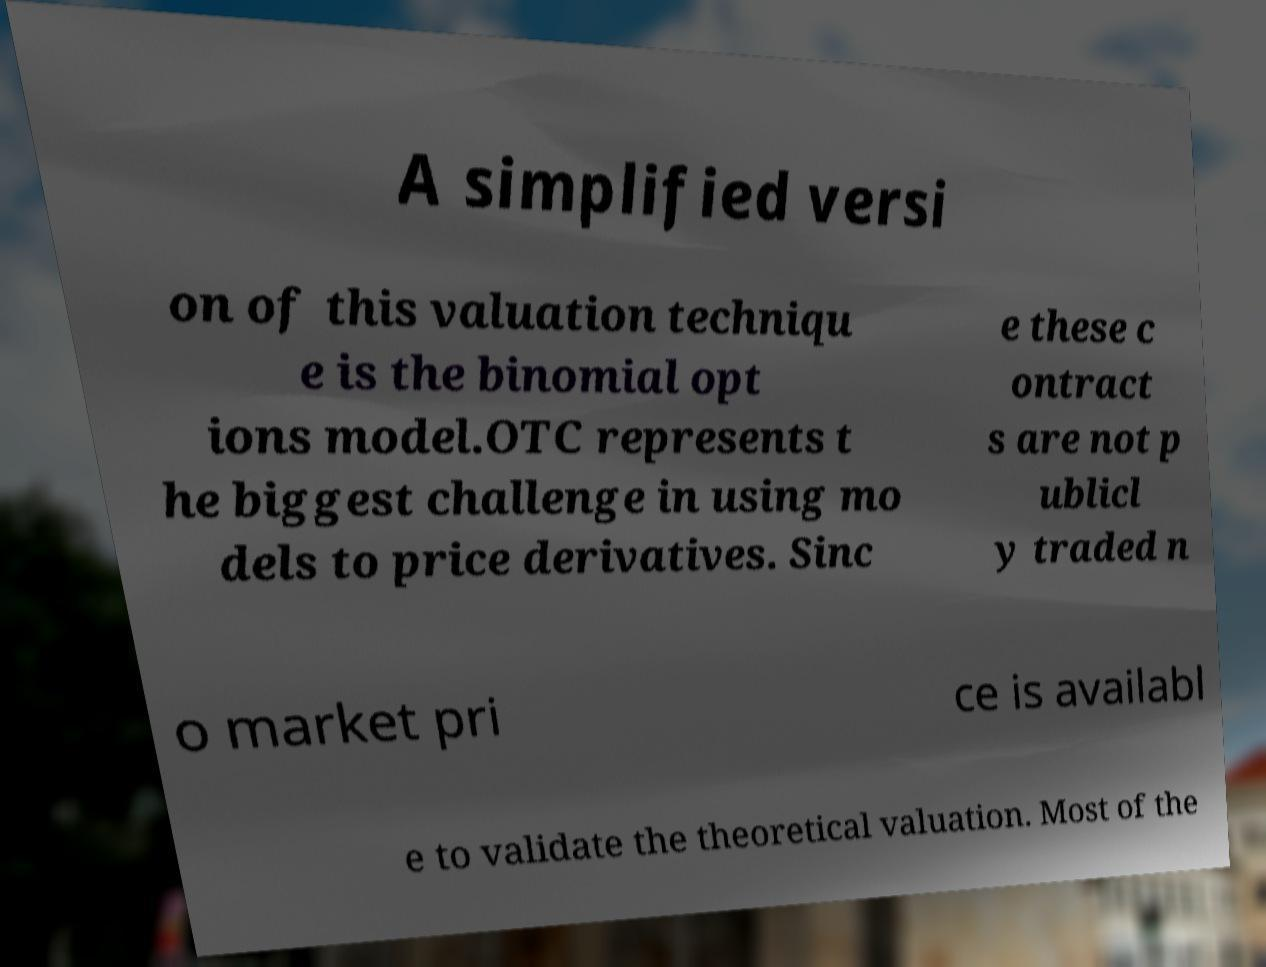Can you accurately transcribe the text from the provided image for me? A simplified versi on of this valuation techniqu e is the binomial opt ions model.OTC represents t he biggest challenge in using mo dels to price derivatives. Sinc e these c ontract s are not p ublicl y traded n o market pri ce is availabl e to validate the theoretical valuation. Most of the 